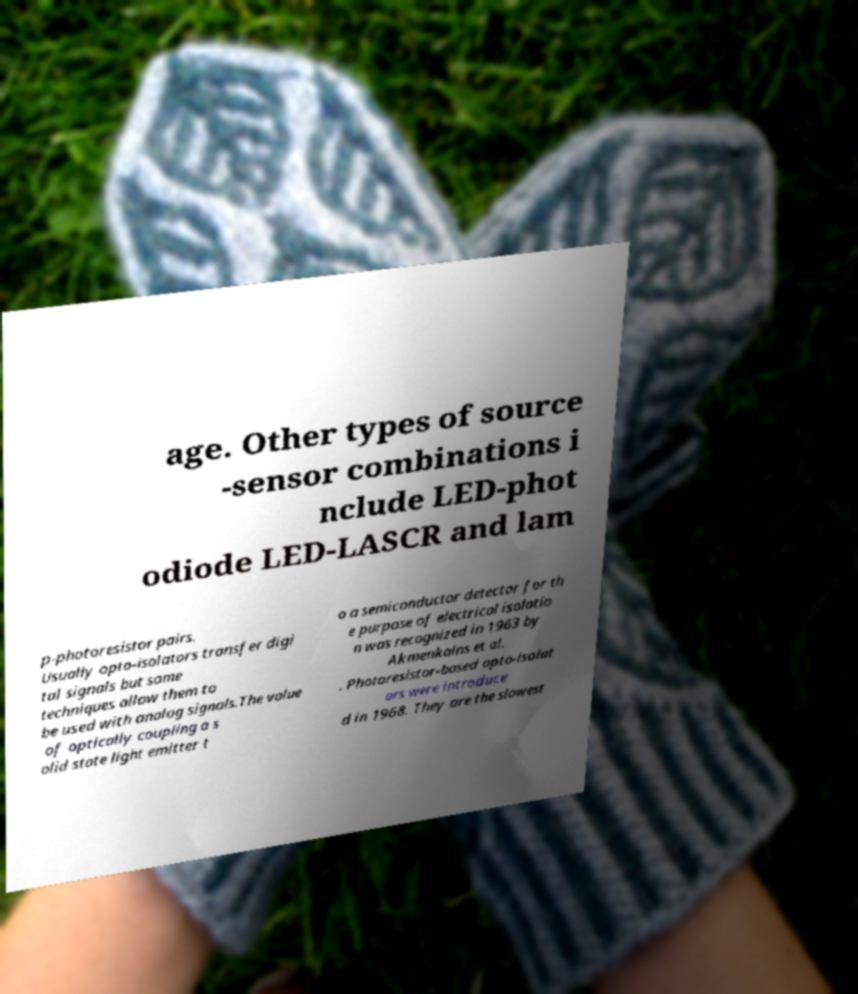There's text embedded in this image that I need extracted. Can you transcribe it verbatim? age. Other types of source -sensor combinations i nclude LED-phot odiode LED-LASCR and lam p-photoresistor pairs. Usually opto-isolators transfer digi tal signals but some techniques allow them to be used with analog signals.The value of optically coupling a s olid state light emitter t o a semiconductor detector for th e purpose of electrical isolatio n was recognized in 1963 by Akmenkalns et al. . Photoresistor-based opto-isolat ors were introduce d in 1968. They are the slowest 